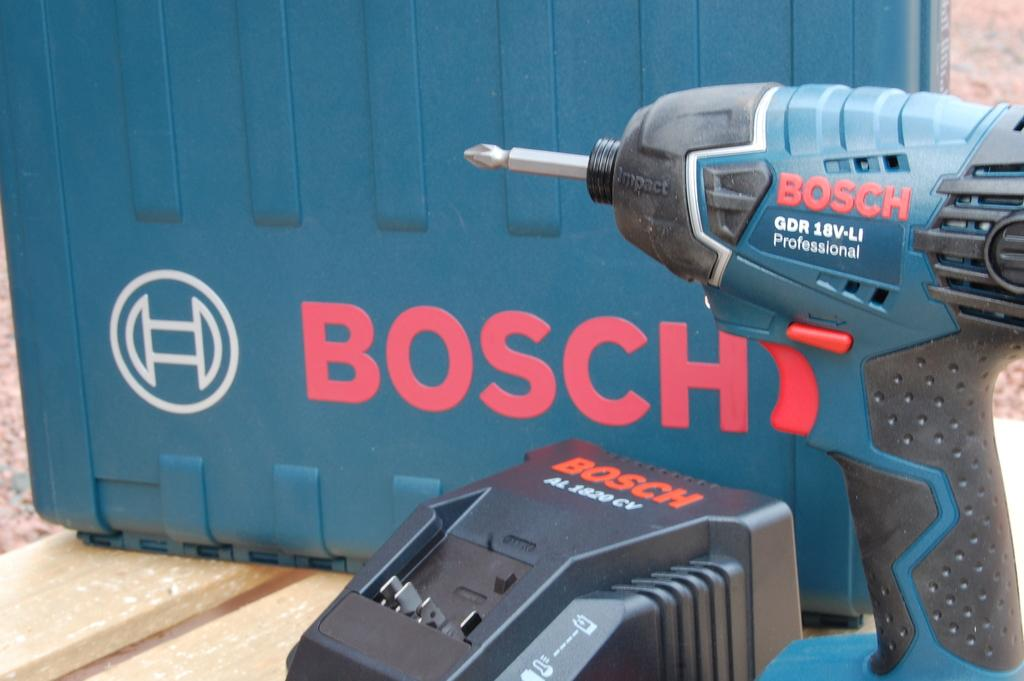What is the main subject of the image? The main subject of the image is a drilling machine. What else can be seen in the image besides the drilling machine? There is other equipment in front of the drilling machine. What type of clouds can be seen in the image? There are no clouds visible in the image, as it focuses on the drilling machine and other equipment. 